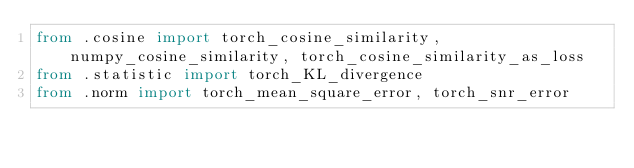<code> <loc_0><loc_0><loc_500><loc_500><_Python_>from .cosine import torch_cosine_similarity, numpy_cosine_similarity, torch_cosine_similarity_as_loss
from .statistic import torch_KL_divergence
from .norm import torch_mean_square_error, torch_snr_error
</code> 